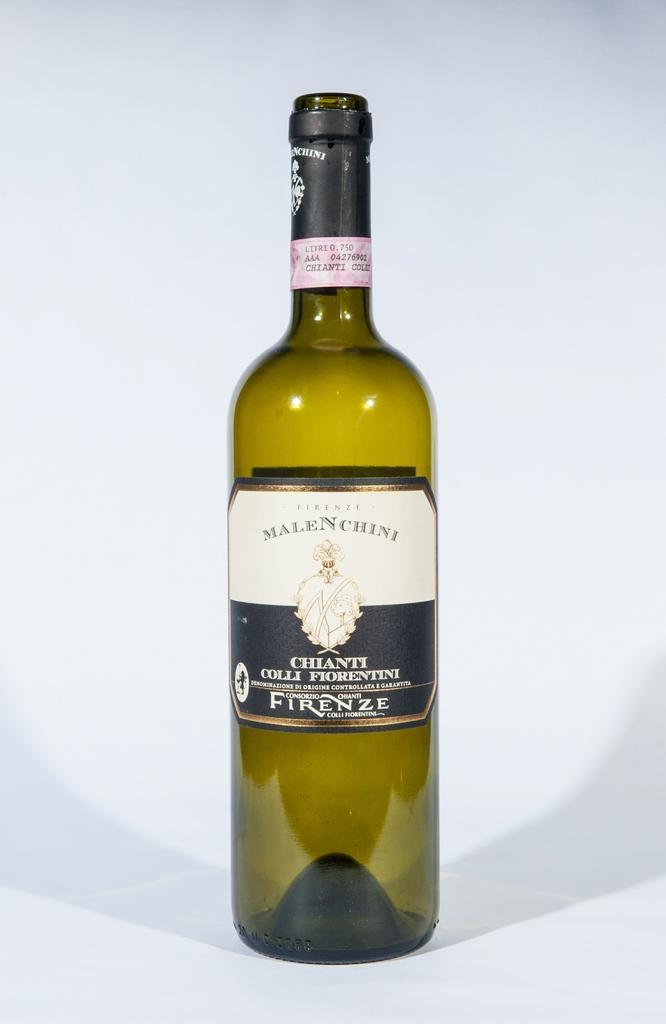Can you describe this image briefly? In this image I see a bottle. 